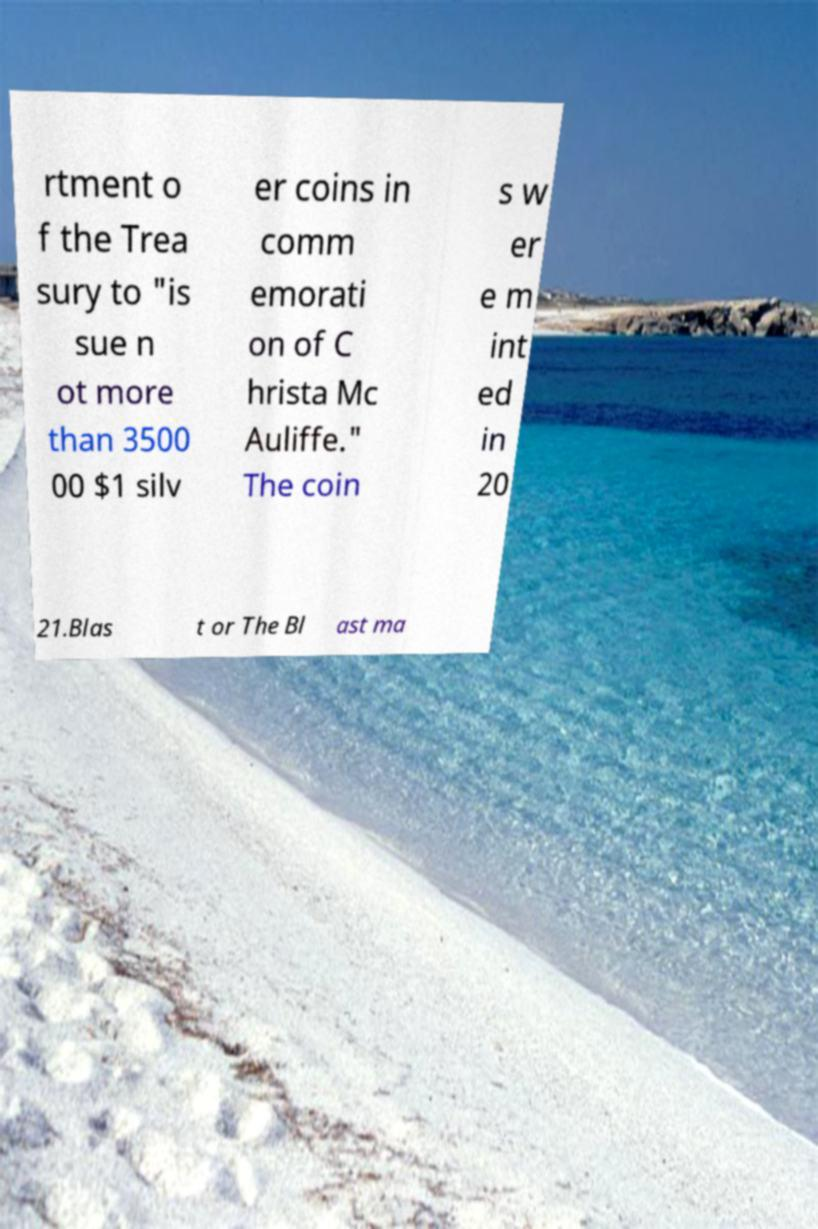Please identify and transcribe the text found in this image. rtment o f the Trea sury to "is sue n ot more than 3500 00 $1 silv er coins in comm emorati on of C hrista Mc Auliffe." The coin s w er e m int ed in 20 21.Blas t or The Bl ast ma 